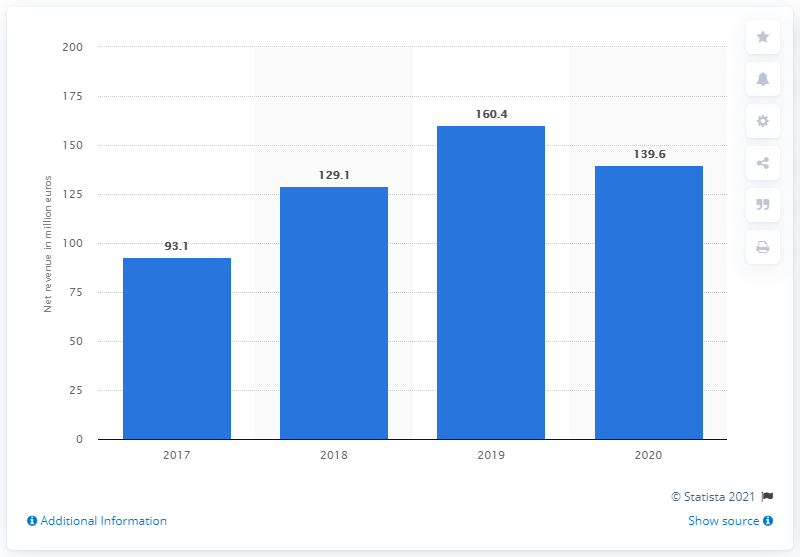Identify some key points in this picture. Jumia generated a total revenue of 139.6 million in 2020. 